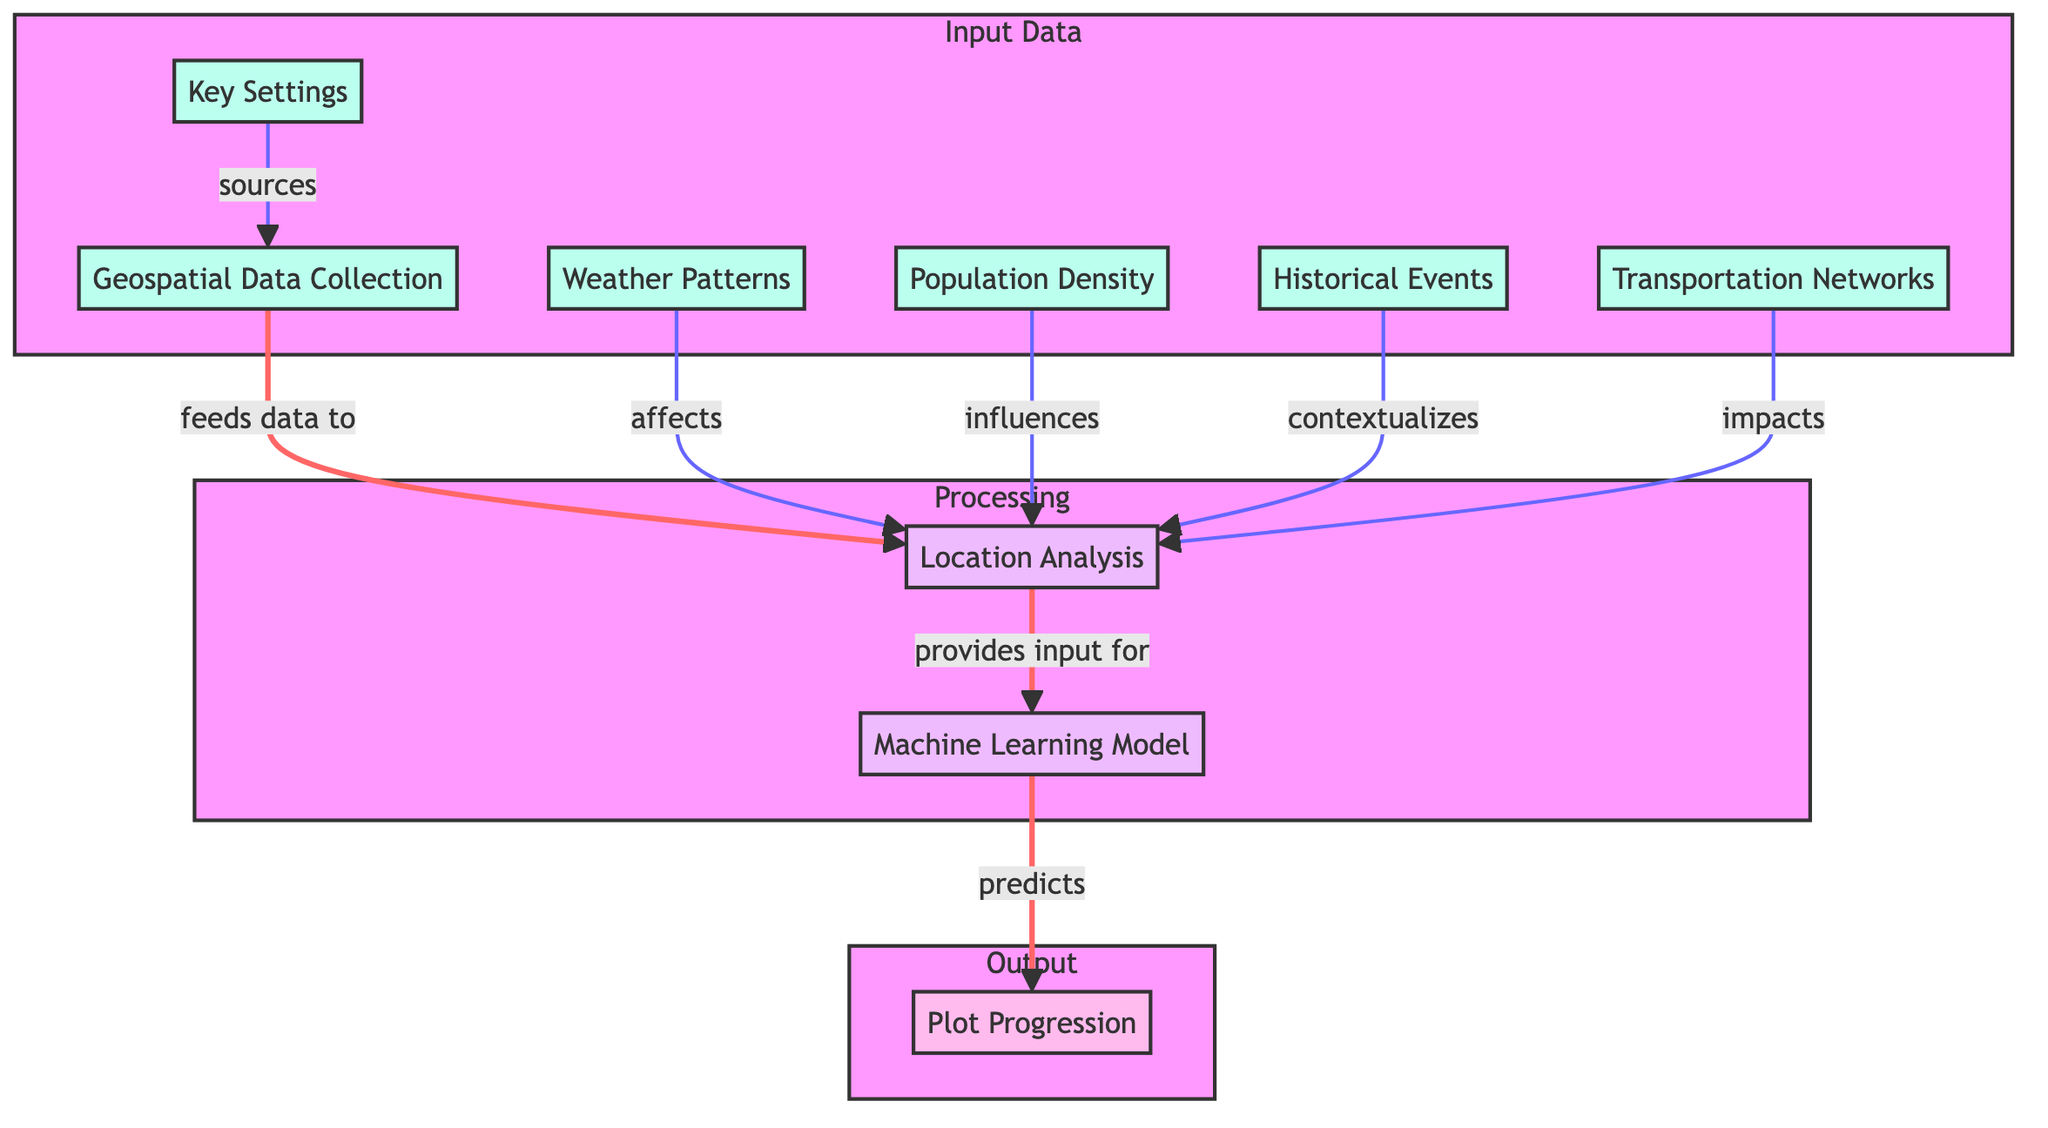What are the inputs to the geospatial data collection? The inputs to the geospatial data collection include key settings, weather patterns, population density, historical events, and transportation networks as shown in the diagram.
Answer: key settings, weather patterns, population density, historical events, transportation networks How many nodes are present in the processing section? The processing section contains two nodes, which are location analysis and machine learning model.
Answer: 2 What is the output of the machine learning model? The output of the machine learning model is plot progression, as indicated by the arrow leading from the machine learning model to the plot progression node.
Answer: plot progression Which input influences location analysis? Population density influences location analysis, as shown by the arrow linking the population density input to the location analysis process.
Answer: population density How are key settings related to geospatial data collection? Key settings source data for geospatial data collection, as represented in the diagram by the arrow that connects key settings to geospatial data collection.
Answer: sources What is the relationship between transportation networks and location analysis? Transportation networks impact location analysis, demonstrated by the arrow indicating that transportation networks contribute to the location analysis process.
Answer: impacts How many total inputs are indicated in the diagram? The diagram indicates a total of five inputs: key settings, weather patterns, population density, historical events, and transportation networks.
Answer: 5 What does the location analysis provide input for? Location analysis provides input for the machine learning model, as shown by the directed arrow in the diagram moving from location analysis to machine learning model.
Answer: machine learning model Which factor contextualizes location analysis? Historical events contextualize location analysis, as depicted by the arrow connecting historical events to location analysis in the diagram.
Answer: contextualizes 